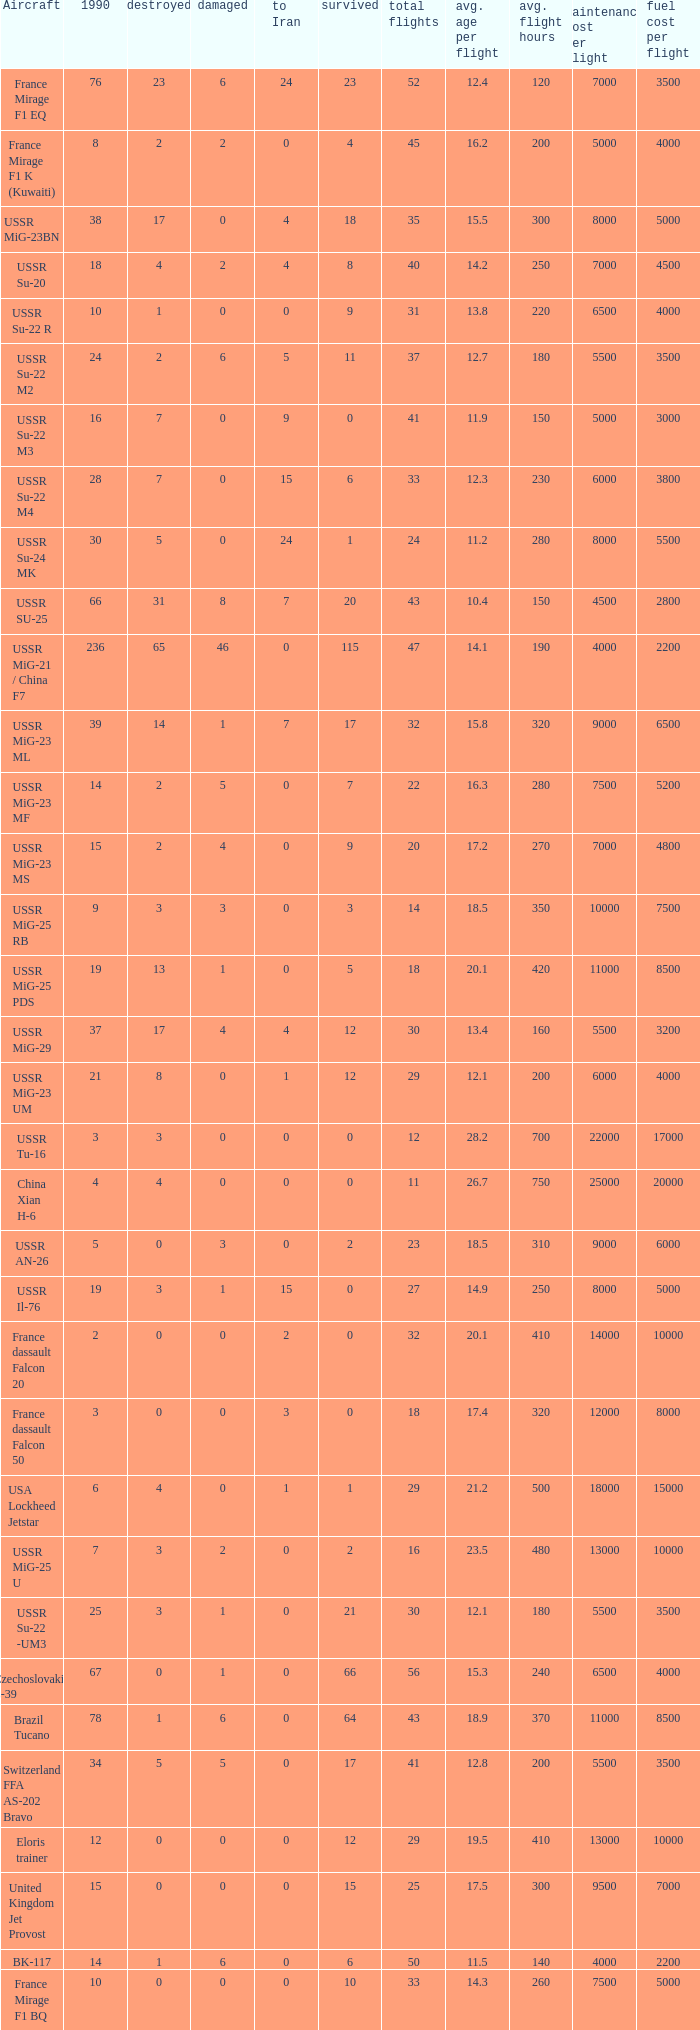If the aircraft was  ussr mig-25 rb how many were destroyed? 3.0. 